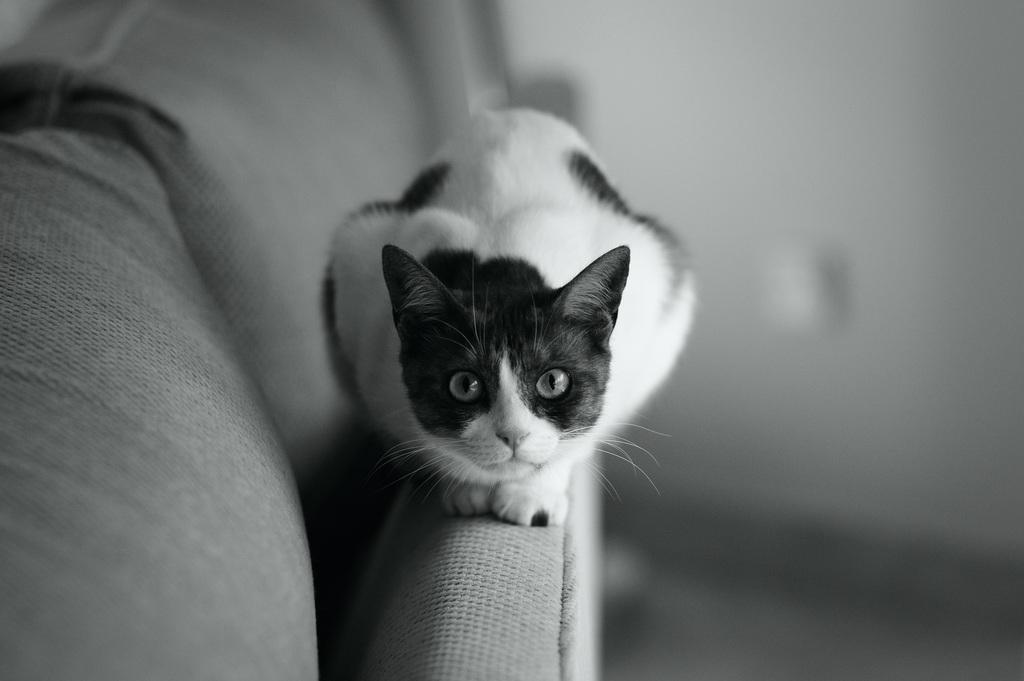How would you summarize this image in a sentence or two? In the image we can see there is a cat which is sitting on the sofa and the image is in black and white colour. 